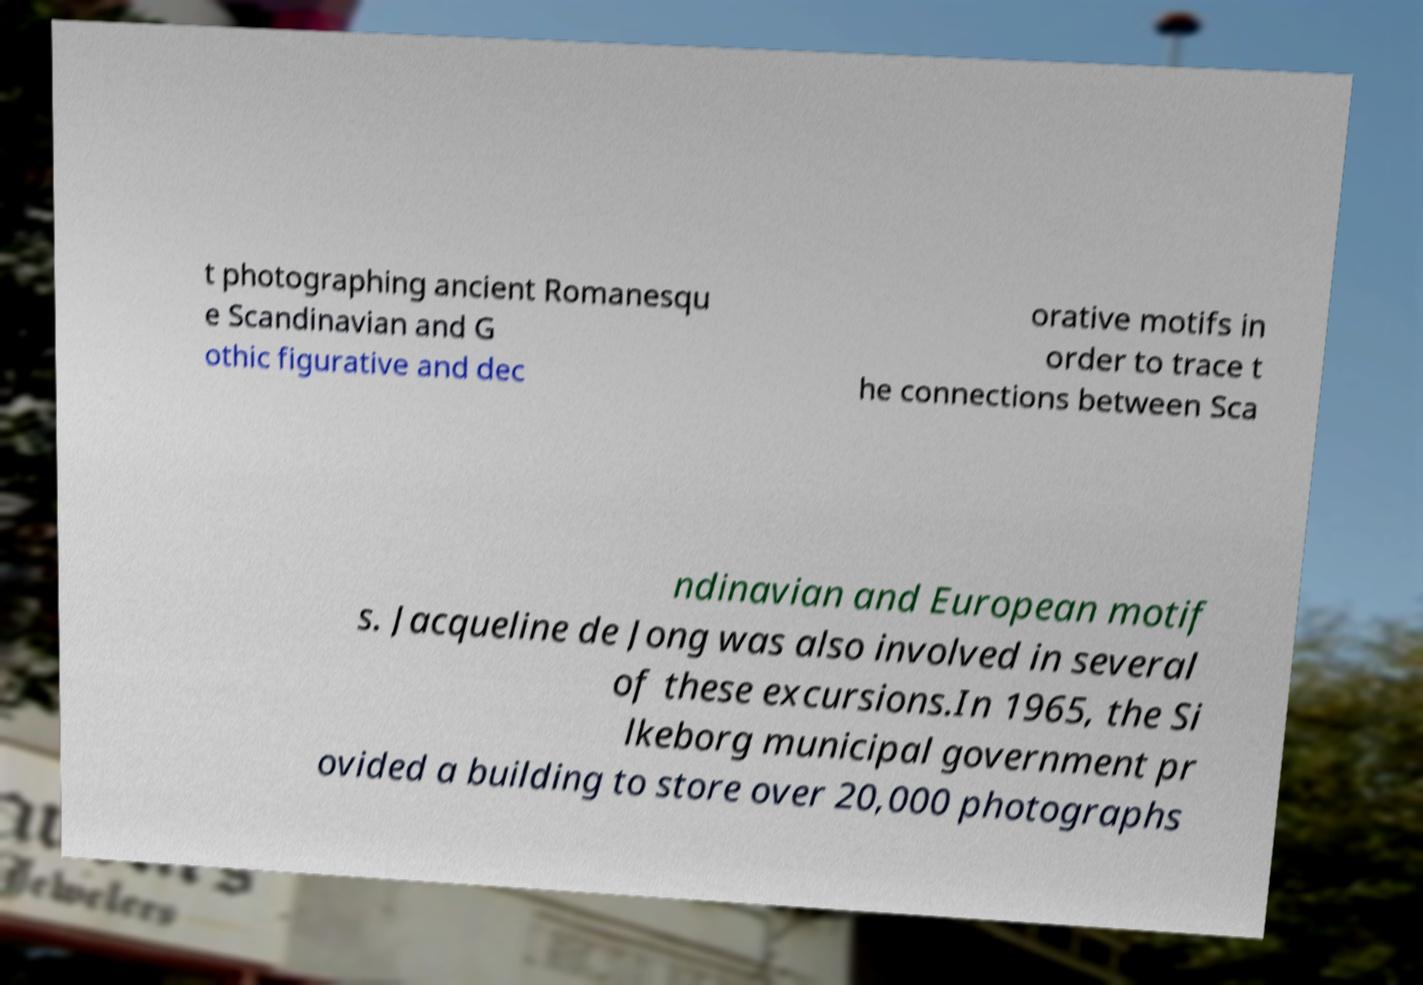Please read and relay the text visible in this image. What does it say? t photographing ancient Romanesqu e Scandinavian and G othic figurative and dec orative motifs in order to trace t he connections between Sca ndinavian and European motif s. Jacqueline de Jong was also involved in several of these excursions.In 1965, the Si lkeborg municipal government pr ovided a building to store over 20,000 photographs 